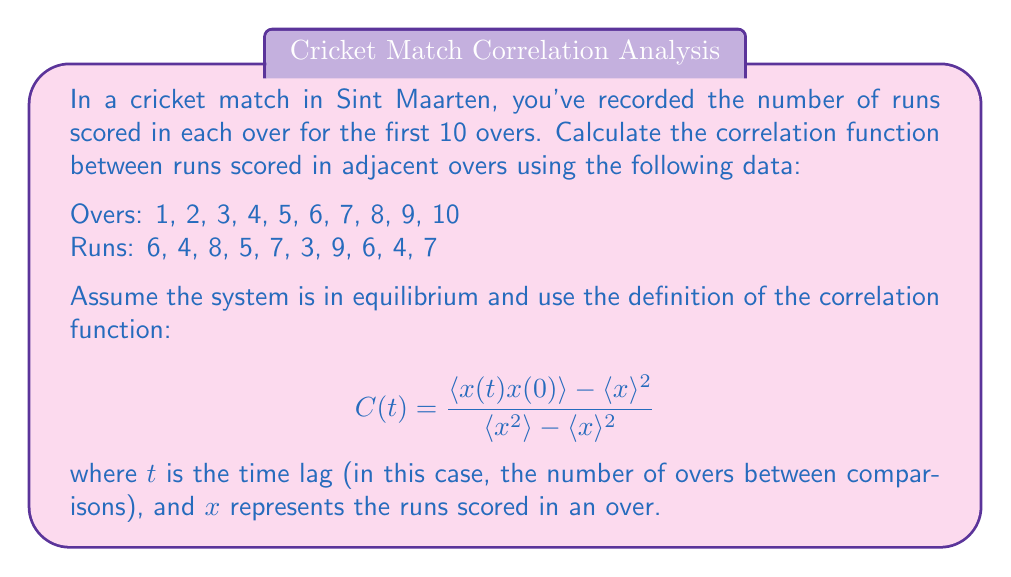Teach me how to tackle this problem. To solve this problem, we'll follow these steps:

1. Calculate the mean runs per over: $\langle x \rangle$
2. Calculate the mean squared runs per over: $\langle x^2 \rangle$
3. Calculate $\langle x(t)x(0) \rangle$ for $t = 1$ (adjacent overs)
4. Apply the correlation function formula

Step 1: Calculate $\langle x \rangle$
$\langle x \rangle = \frac{1}{10}(6 + 4 + 8 + 5 + 7 + 3 + 9 + 6 + 4 + 7) = 5.9$

Step 2: Calculate $\langle x^2 \rangle$
$\langle x^2 \rangle = \frac{1}{10}(6^2 + 4^2 + 8^2 + 5^2 + 7^2 + 3^2 + 9^2 + 6^2 + 4^2 + 7^2) = 38.1$

Step 3: Calculate $\langle x(t)x(0) \rangle$ for $t = 1$
For adjacent overs, we multiply each pair and take the average:
$\langle x(1)x(0) \rangle = \frac{1}{9}(6 \cdot 4 + 4 \cdot 8 + 8 \cdot 5 + 5 \cdot 7 + 7 \cdot 3 + 3 \cdot 9 + 9 \cdot 6 + 6 \cdot 4 + 4 \cdot 7) = 34.11111...$

Step 4: Apply the correlation function formula
$$ C(1) = \frac{\langle x(1)x(0) \rangle - \langle x \rangle^2}{\langle x^2 \rangle - \langle x \rangle^2} $$

$$ C(1) = \frac{34.11111... - 5.9^2}{38.1 - 5.9^2} = \frac{34.11111... - 34.81}{38.1 - 34.81} \approx -0.2121 $$
Answer: $C(1) \approx -0.2121$ 